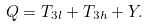Convert formula to latex. <formula><loc_0><loc_0><loc_500><loc_500>Q = T _ { 3 l } + T _ { 3 h } + Y .</formula> 